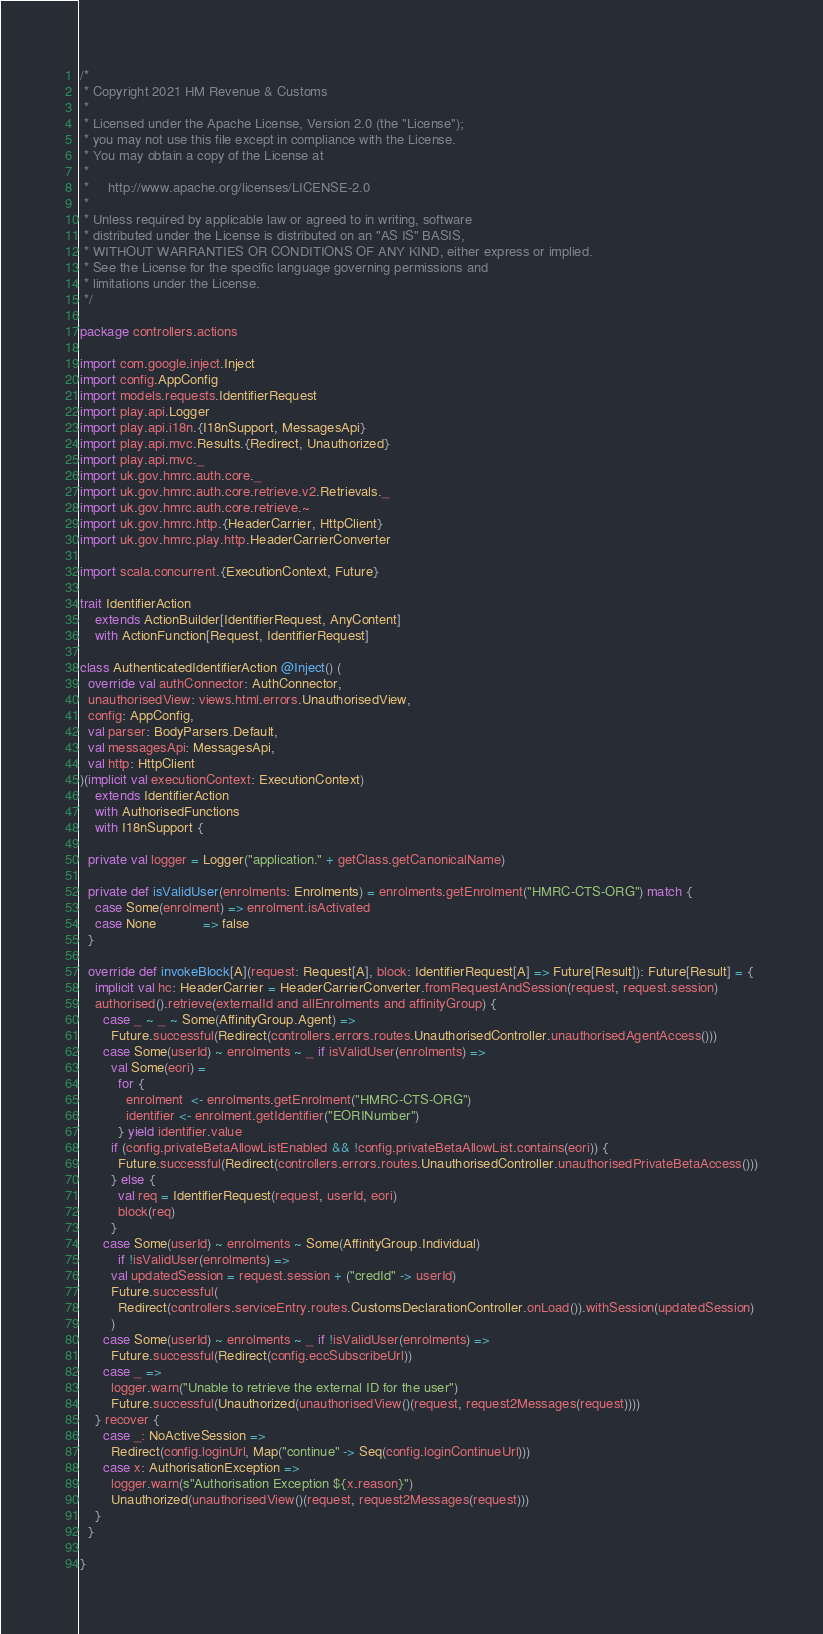<code> <loc_0><loc_0><loc_500><loc_500><_Scala_>/*
 * Copyright 2021 HM Revenue & Customs
 *
 * Licensed under the Apache License, Version 2.0 (the "License");
 * you may not use this file except in compliance with the License.
 * You may obtain a copy of the License at
 *
 *     http://www.apache.org/licenses/LICENSE-2.0
 *
 * Unless required by applicable law or agreed to in writing, software
 * distributed under the License is distributed on an "AS IS" BASIS,
 * WITHOUT WARRANTIES OR CONDITIONS OF ANY KIND, either express or implied.
 * See the License for the specific language governing permissions and
 * limitations under the License.
 */

package controllers.actions

import com.google.inject.Inject
import config.AppConfig
import models.requests.IdentifierRequest
import play.api.Logger
import play.api.i18n.{I18nSupport, MessagesApi}
import play.api.mvc.Results.{Redirect, Unauthorized}
import play.api.mvc._
import uk.gov.hmrc.auth.core._
import uk.gov.hmrc.auth.core.retrieve.v2.Retrievals._
import uk.gov.hmrc.auth.core.retrieve.~
import uk.gov.hmrc.http.{HeaderCarrier, HttpClient}
import uk.gov.hmrc.play.http.HeaderCarrierConverter

import scala.concurrent.{ExecutionContext, Future}

trait IdentifierAction
    extends ActionBuilder[IdentifierRequest, AnyContent]
    with ActionFunction[Request, IdentifierRequest]

class AuthenticatedIdentifierAction @Inject() (
  override val authConnector: AuthConnector,
  unauthorisedView: views.html.errors.UnauthorisedView,
  config: AppConfig,
  val parser: BodyParsers.Default,
  val messagesApi: MessagesApi,
  val http: HttpClient
)(implicit val executionContext: ExecutionContext)
    extends IdentifierAction
    with AuthorisedFunctions
    with I18nSupport {

  private val logger = Logger("application." + getClass.getCanonicalName)

  private def isValidUser(enrolments: Enrolments) = enrolments.getEnrolment("HMRC-CTS-ORG") match {
    case Some(enrolment) => enrolment.isActivated
    case None            => false
  }

  override def invokeBlock[A](request: Request[A], block: IdentifierRequest[A] => Future[Result]): Future[Result] = {
    implicit val hc: HeaderCarrier = HeaderCarrierConverter.fromRequestAndSession(request, request.session)
    authorised().retrieve(externalId and allEnrolments and affinityGroup) {
      case _ ~ _ ~ Some(AffinityGroup.Agent) =>
        Future.successful(Redirect(controllers.errors.routes.UnauthorisedController.unauthorisedAgentAccess()))
      case Some(userId) ~ enrolments ~ _ if isValidUser(enrolments) =>
        val Some(eori) =
          for {
            enrolment  <- enrolments.getEnrolment("HMRC-CTS-ORG")
            identifier <- enrolment.getIdentifier("EORINumber")
          } yield identifier.value
        if (config.privateBetaAllowListEnabled && !config.privateBetaAllowList.contains(eori)) {
          Future.successful(Redirect(controllers.errors.routes.UnauthorisedController.unauthorisedPrivateBetaAccess()))
        } else {
          val req = IdentifierRequest(request, userId, eori)
          block(req)
        }
      case Some(userId) ~ enrolments ~ Some(AffinityGroup.Individual)
          if !isValidUser(enrolments) =>
        val updatedSession = request.session + ("credId" -> userId)
        Future.successful(
          Redirect(controllers.serviceEntry.routes.CustomsDeclarationController.onLoad()).withSession(updatedSession)
        )
      case Some(userId) ~ enrolments ~ _ if !isValidUser(enrolments) =>
        Future.successful(Redirect(config.eccSubscribeUrl))
      case _ =>
        logger.warn("Unable to retrieve the external ID for the user")
        Future.successful(Unauthorized(unauthorisedView()(request, request2Messages(request))))
    } recover {
      case _: NoActiveSession =>
        Redirect(config.loginUrl, Map("continue" -> Seq(config.loginContinueUrl)))
      case x: AuthorisationException =>
        logger.warn(s"Authorisation Exception ${x.reason}")
        Unauthorized(unauthorisedView()(request, request2Messages(request)))
    }
  }

}
</code> 